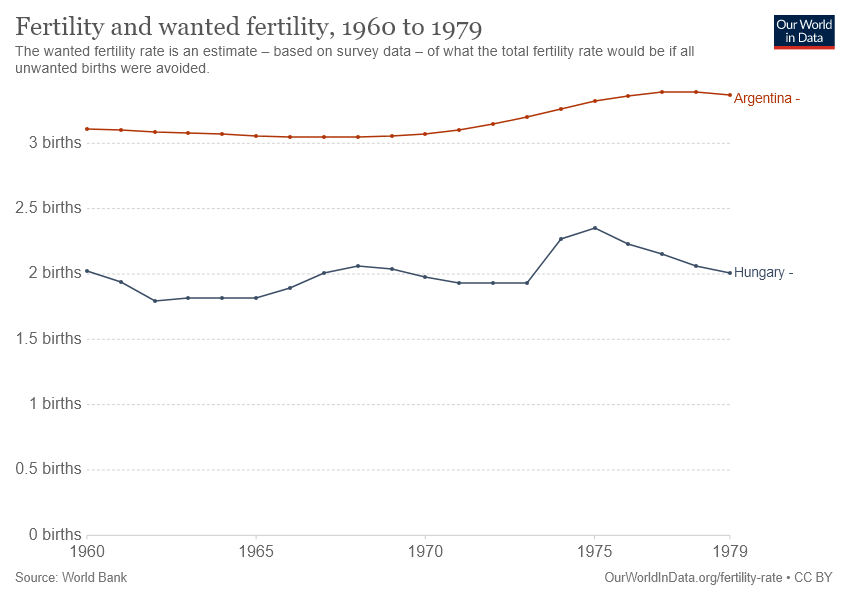Indicate a few pertinent items in this graphic. The given graph compares Argentina and Hungary. The country depicted by the blue line in the graph is Hungary. 